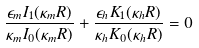<formula> <loc_0><loc_0><loc_500><loc_500>\frac { \epsilon _ { m } I _ { 1 } ( \kappa _ { m } R ) } { \kappa _ { m } I _ { 0 } ( \kappa _ { m } R ) } + \frac { \epsilon _ { h } K _ { 1 } ( \kappa _ { h } R ) } { \kappa _ { h } K _ { 0 } ( \kappa _ { h } R ) } = 0</formula> 